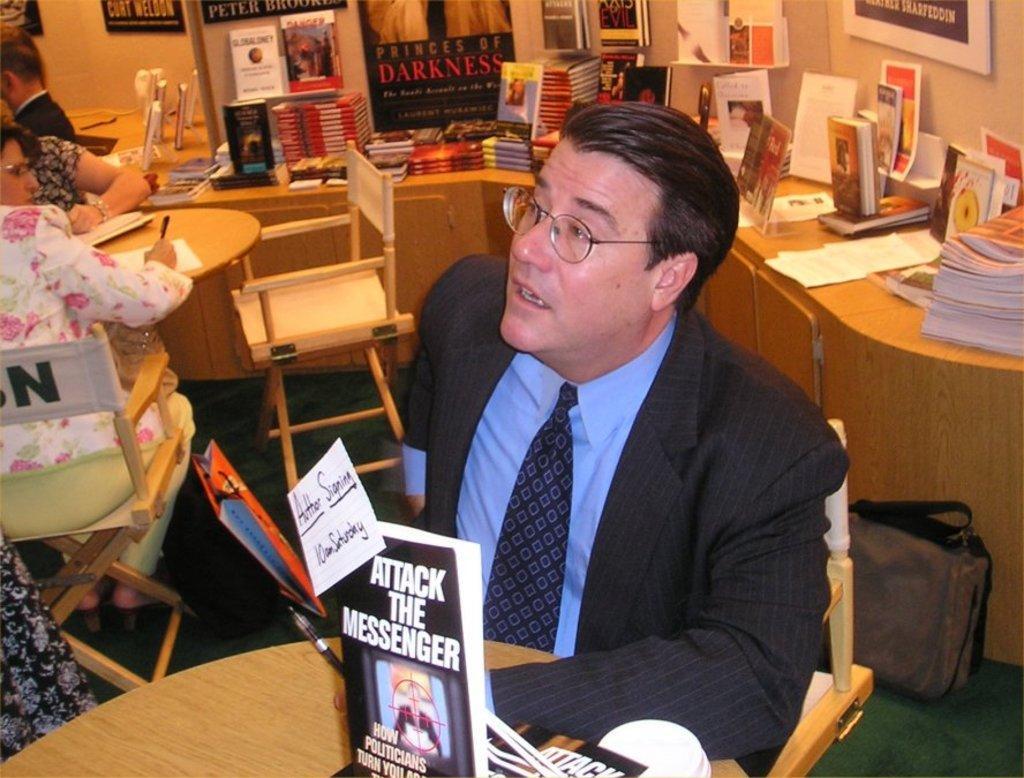Could you give a brief overview of what you see in this image? In this image I can see few people are sitting in front of the table. On the table there is a book,paper and the pen. In the back ground there are so many books and some of the boards attached to the wall. 